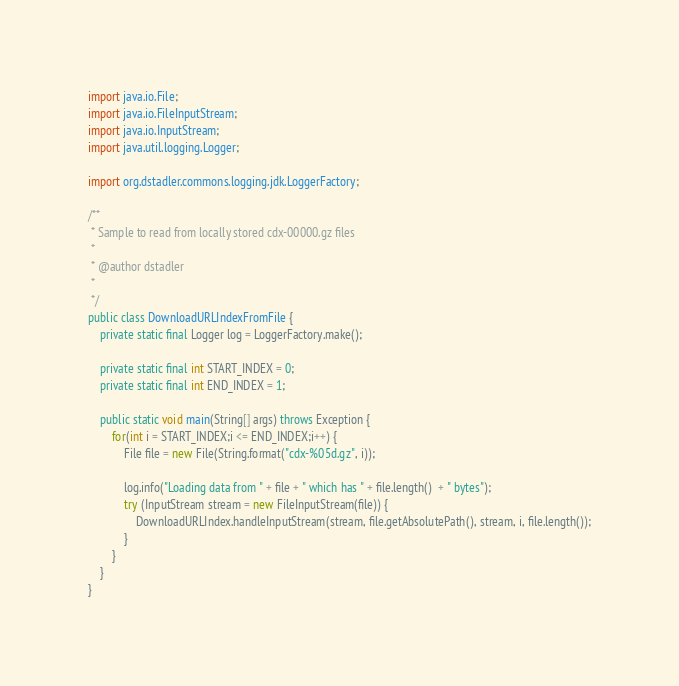<code> <loc_0><loc_0><loc_500><loc_500><_Java_>import java.io.File;
import java.io.FileInputStream;
import java.io.InputStream;
import java.util.logging.Logger;

import org.dstadler.commons.logging.jdk.LoggerFactory;

/**
 * Sample to read from locally stored cdx-00000.gz files
 *
 * @author dstadler
 *
 */
public class DownloadURLIndexFromFile {
    private static final Logger log = LoggerFactory.make();

    private static final int START_INDEX = 0;
    private static final int END_INDEX = 1;

	public static void main(String[] args) throws Exception {
		for(int i = START_INDEX;i <= END_INDEX;i++) {
			File file = new File(String.format("cdx-%05d.gz", i));

	    	log.info("Loading data from " + file + " which has " + file.length()  + " bytes");
		    try (InputStream stream = new FileInputStream(file)) {
		    	DownloadURLIndex.handleInputStream(stream, file.getAbsolutePath(), stream, i, file.length());
	        }
		}
	}
}
</code> 